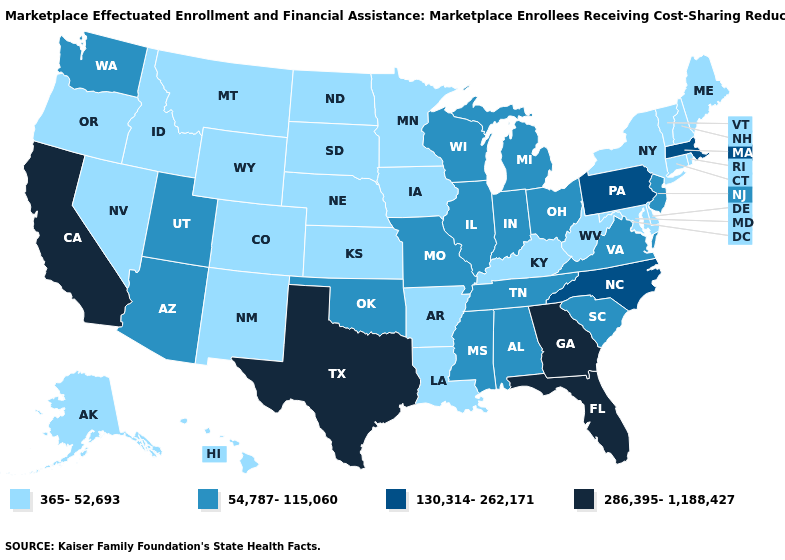What is the lowest value in states that border Delaware?
Give a very brief answer. 365-52,693. Name the states that have a value in the range 365-52,693?
Keep it brief. Alaska, Arkansas, Colorado, Connecticut, Delaware, Hawaii, Idaho, Iowa, Kansas, Kentucky, Louisiana, Maine, Maryland, Minnesota, Montana, Nebraska, Nevada, New Hampshire, New Mexico, New York, North Dakota, Oregon, Rhode Island, South Dakota, Vermont, West Virginia, Wyoming. Which states hav the highest value in the West?
Keep it brief. California. Does Missouri have the same value as Tennessee?
Give a very brief answer. Yes. Which states hav the highest value in the MidWest?
Answer briefly. Illinois, Indiana, Michigan, Missouri, Ohio, Wisconsin. Does Colorado have the lowest value in the USA?
Keep it brief. Yes. Does Kansas have the highest value in the MidWest?
Give a very brief answer. No. Name the states that have a value in the range 54,787-115,060?
Keep it brief. Alabama, Arizona, Illinois, Indiana, Michigan, Mississippi, Missouri, New Jersey, Ohio, Oklahoma, South Carolina, Tennessee, Utah, Virginia, Washington, Wisconsin. Name the states that have a value in the range 365-52,693?
Short answer required. Alaska, Arkansas, Colorado, Connecticut, Delaware, Hawaii, Idaho, Iowa, Kansas, Kentucky, Louisiana, Maine, Maryland, Minnesota, Montana, Nebraska, Nevada, New Hampshire, New Mexico, New York, North Dakota, Oregon, Rhode Island, South Dakota, Vermont, West Virginia, Wyoming. Which states have the highest value in the USA?
Answer briefly. California, Florida, Georgia, Texas. What is the lowest value in the USA?
Be succinct. 365-52,693. What is the lowest value in the Northeast?
Write a very short answer. 365-52,693. Does Colorado have the same value as Wyoming?
Answer briefly. Yes. Is the legend a continuous bar?
Be succinct. No. What is the lowest value in the South?
Give a very brief answer. 365-52,693. 